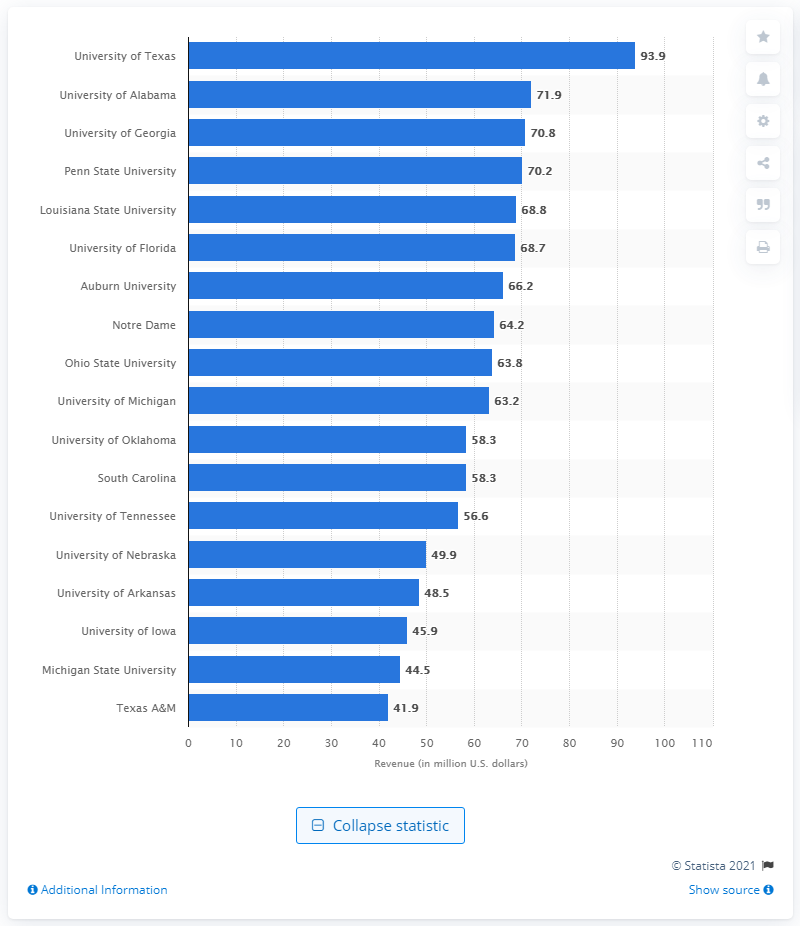Which university has the lowest revenue on this chart, and what is the amount? Texas A&M has the lowest revenue on the chart, with an amount of approximately $41.9 million. 